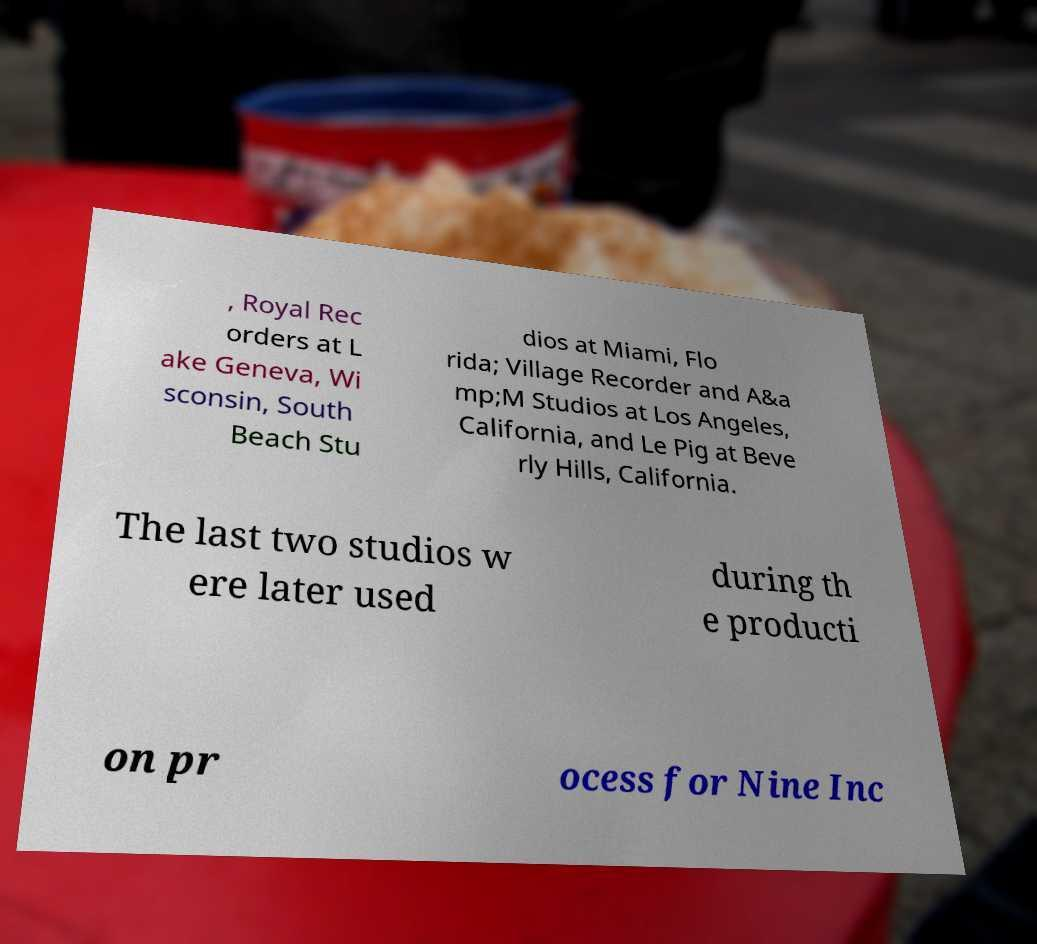I need the written content from this picture converted into text. Can you do that? , Royal Rec orders at L ake Geneva, Wi sconsin, South Beach Stu dios at Miami, Flo rida; Village Recorder and A&a mp;M Studios at Los Angeles, California, and Le Pig at Beve rly Hills, California. The last two studios w ere later used during th e producti on pr ocess for Nine Inc 